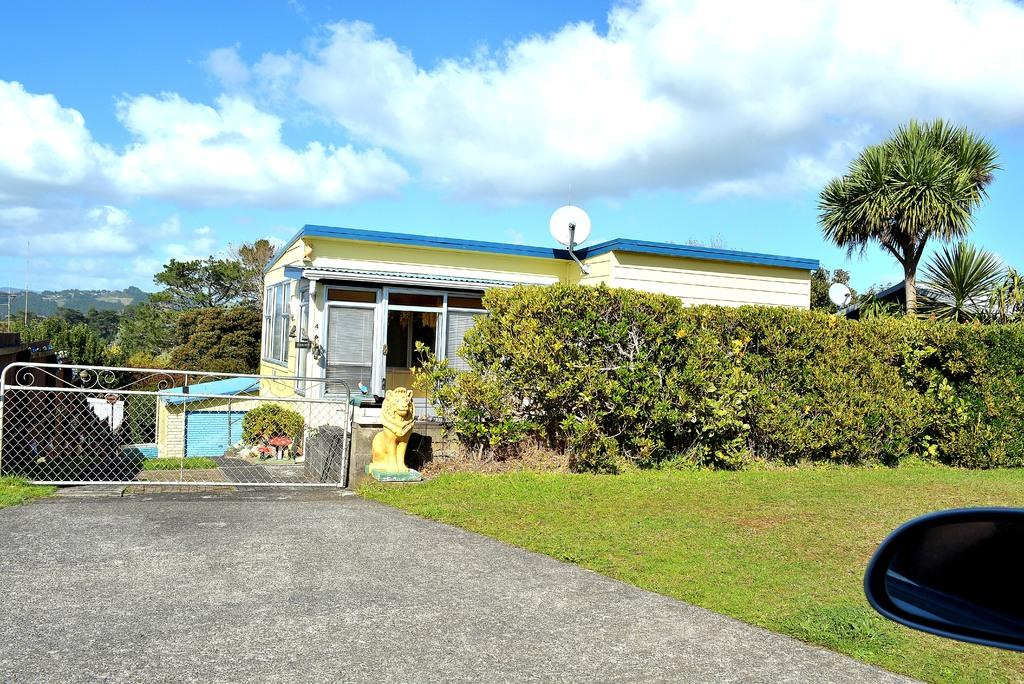What type of reflective surface can be seen in the image? There is a side mirror in the image. What other object with a transparent or translucent property is present in the image? There is a glass element in the image. What type of artwork or sculpture is visible in the image? There is a statue in the image. What type of landscaping element is present in the image? There is a hedge in the image. What type of entrance or barrier is visible in the image? There is a gate in the image. What type of structures are visible behind the gate? Houses are visible behind the gate. What type of vegetation is visible behind the houses? Trees are visible behind the houses. What type of natural landform is visible in the background? Hills are visible in the background. What else is visible in the background? The sky is visible in the background. Where is the playground located in the image? There is no playground present in the image. What type of limb is visible on the statue in the image? The statue in the image does not have any limbs, as it is not a human or animal figure. What type of occupation is represented by the person in the image? There is no person present in the image, so it is not possible to determine their occupation. 